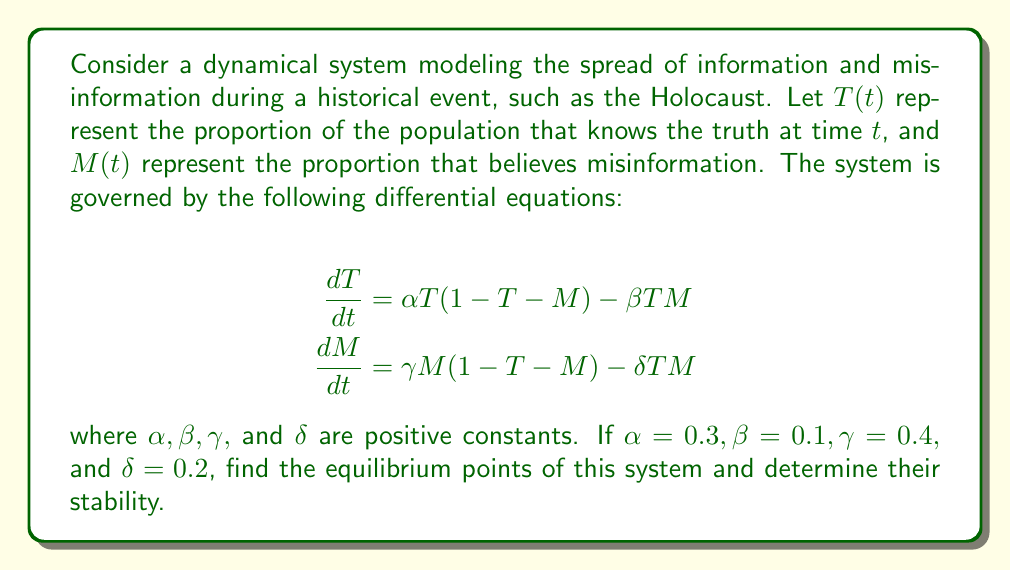Provide a solution to this math problem. To solve this problem, we'll follow these steps:

1) Find the equilibrium points by setting both derivatives to zero:

   $$\frac{dT}{dt} = 0.3T(1-T-M) - 0.1TM = 0$$
   $$\frac{dM}{dt} = 0.4M(1-T-M) - 0.2TM = 0$$

2) Solve these equations:
   
   From the first equation:
   $T = 0$ or $0.3(1-T-M) - 0.1M = 0$
   
   From the second equation:
   $M = 0$ or $0.4(1-T-M) - 0.2T = 0$

3) We can identify three equilibrium points:

   a) $(0,0)$: No information spread
   b) $(1,0)$: Only truth spreads
   c) $(0,1)$: Only misinformation spreads

4) To find the fourth equilibrium point, solve:

   $0.3(1-T-M) - 0.1M = 0$
   $0.4(1-T-M) - 0.2T = 0$

   Solving these simultaneously gives:
   $T = \frac{6}{13}, M = \frac{4}{13}$

5) To determine stability, we need to find the Jacobian matrix:

   $$J = \begin{bmatrix}
   0.3(1-2T-M)-0.1M & -0.3T-0.1T \\
   -0.4M-0.2M & 0.4(1-T-2M)-0.2T
   \end{bmatrix}$$

6) Evaluate the Jacobian at each equilibrium point and find eigenvalues:

   a) At $(0,0)$: $J = \begin{bmatrix} 0.3 & 0 \\ 0 & 0.4 \end{bmatrix}$
      Eigenvalues: 0.3 and 0.4 (both positive, unstable)
   
   b) At $(1,0)$: $J = \begin{bmatrix} -0.3 & -0.4 \\ 0 & -0.6 \end{bmatrix}$
      Eigenvalues: -0.3 and -0.6 (both negative, stable)
   
   c) At $(0,1)$: $J = \begin{bmatrix} -0.4 & 0 \\ -0.6 & -0.4 \end{bmatrix}$
      Eigenvalues: -0.4 and -0.4 (both negative, stable)
   
   d) At $(\frac{6}{13},\frac{4}{13})$: 
      $J = \begin{bmatrix} -0.1385 & -0.2769 \\ -0.2462 & -0.1846 \end{bmatrix}$
      Eigenvalues: -0.0308 and -0.2923 (both negative, stable)

Therefore, all equilibrium points except $(0,0)$ are stable.
Answer: Equilibrium points: $(0,0)$, $(1,0)$, $(0,1)$, $(\frac{6}{13},\frac{4}{13})$. All stable except $(0,0)$. 